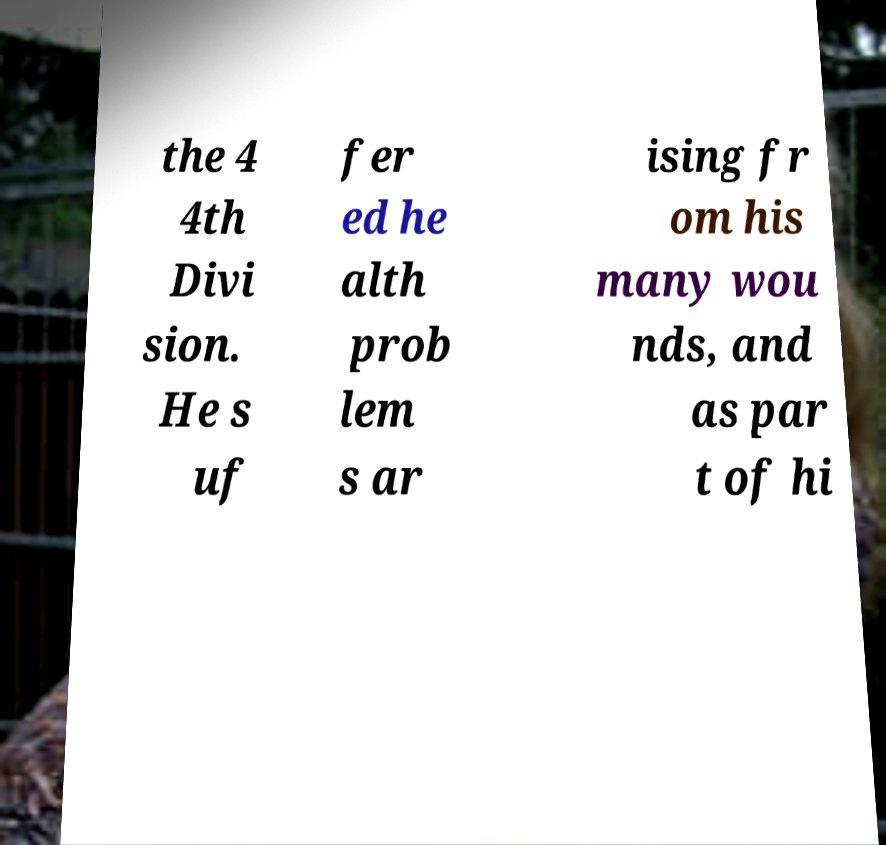Please read and relay the text visible in this image. What does it say? the 4 4th Divi sion. He s uf fer ed he alth prob lem s ar ising fr om his many wou nds, and as par t of hi 